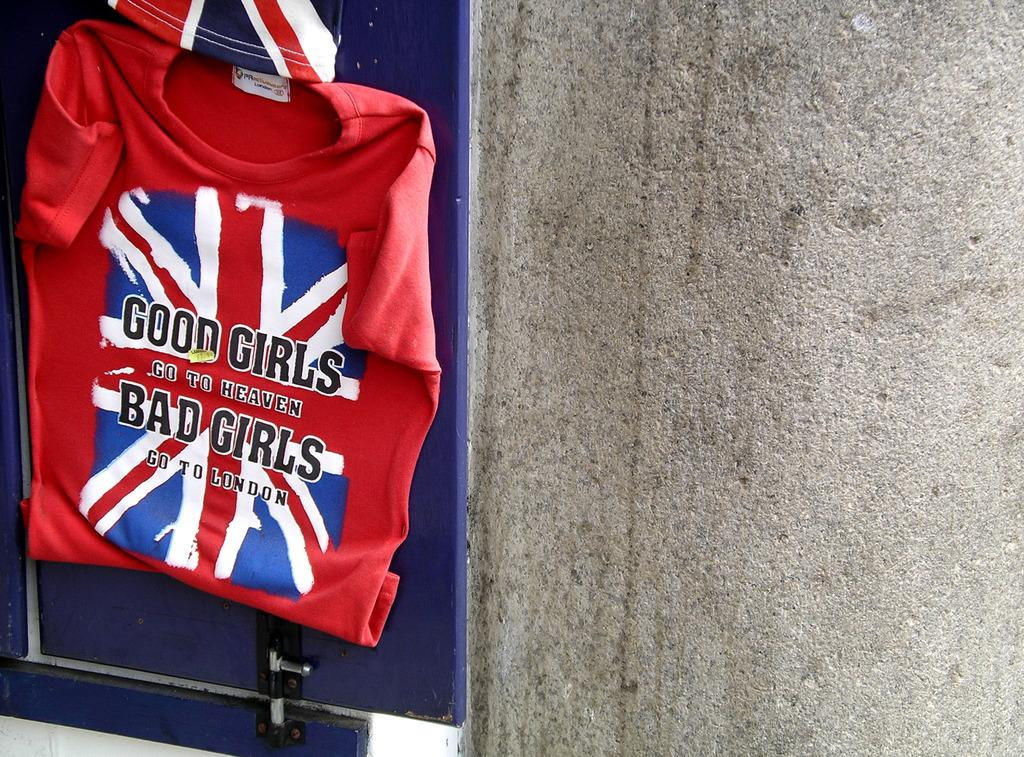<image>
Present a compact description of the photo's key features. a bad girls sign with a flag under it 